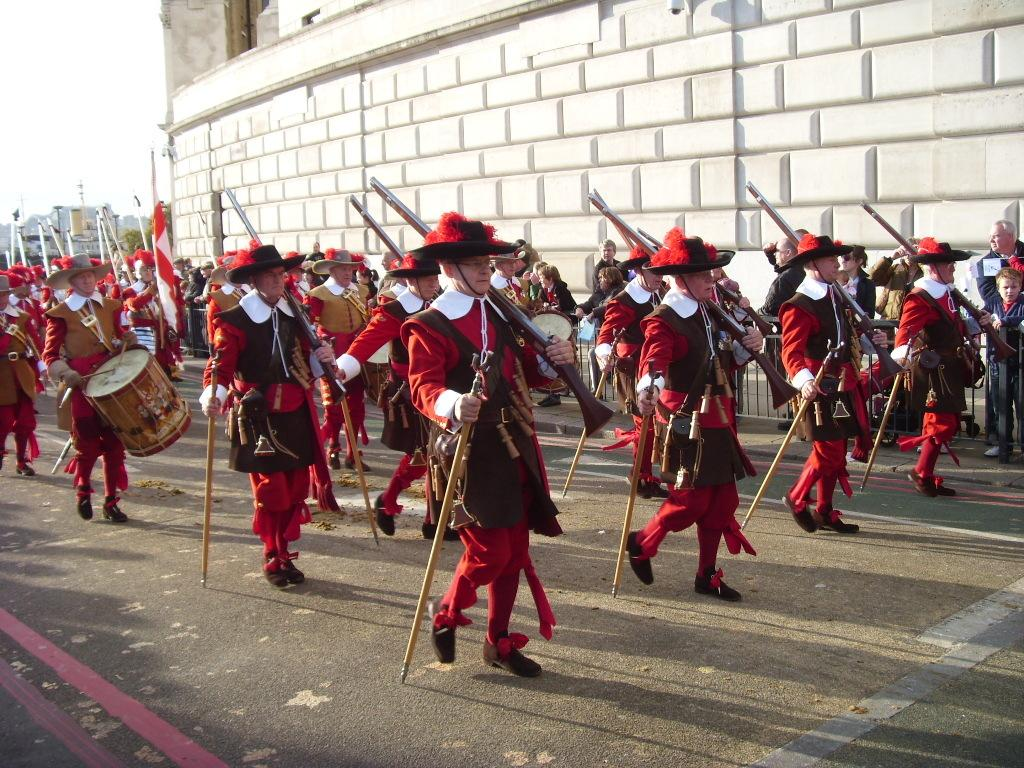What is happening in the image involving a group of people? There is a group of people in the image, and they are walking on the road. What are the people holding in their hands? The people are holding sticks and guns in their hands. What can be seen in the background of the image? There is a wall and buildings in the background of the image. What type of spade is being used to smash the wall in the image? There is no spade or wall-smashing activity present in the image. 